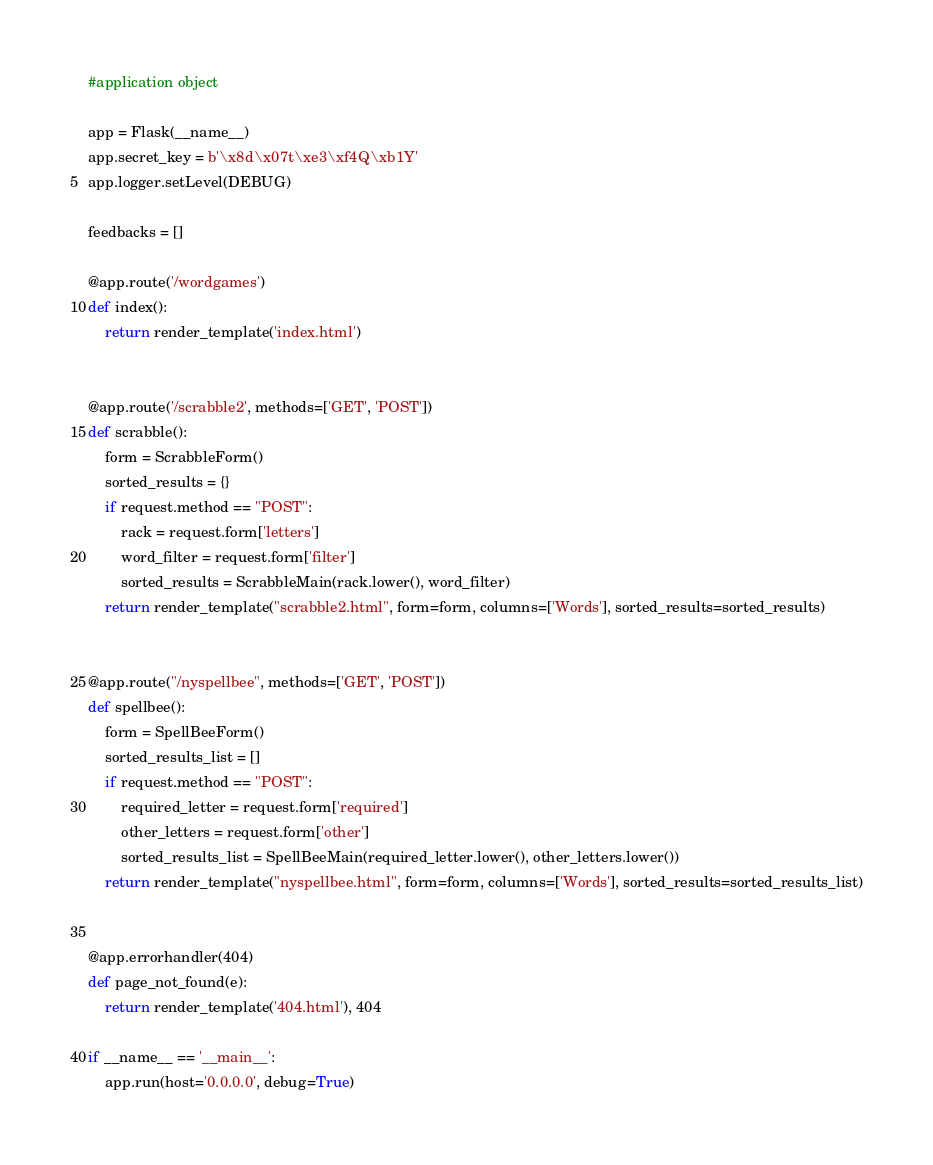<code> <loc_0><loc_0><loc_500><loc_500><_Python_>#application object

app = Flask(__name__)
app.secret_key = b'\x8d\x07t\xe3\xf4Q\xb1Y'
app.logger.setLevel(DEBUG)

feedbacks = []

@app.route('/wordgames')
def index():
	return render_template('index.html')


@app.route('/scrabble2', methods=['GET', 'POST'])
def scrabble():
	form = ScrabbleForm()
	sorted_results = {}
	if request.method == "POST":
		rack = request.form['letters']
		word_filter = request.form['filter']
		sorted_results = ScrabbleMain(rack.lower(), word_filter)
	return render_template("scrabble2.html", form=form, columns=['Words'], sorted_results=sorted_results)


@app.route("/nyspellbee", methods=['GET', 'POST'])
def spellbee():
	form = SpellBeeForm()
	sorted_results_list = []
	if request.method == "POST":
		required_letter = request.form['required']
		other_letters = request.form['other']
		sorted_results_list = SpellBeeMain(required_letter.lower(), other_letters.lower())
	return render_template("nyspellbee.html", form=form, columns=['Words'], sorted_results=sorted_results_list)


@app.errorhandler(404)
def page_not_found(e):
	return render_template('404.html'), 404

if __name__ == '__main__':
	app.run(host='0.0.0.0', debug=True)
</code> 